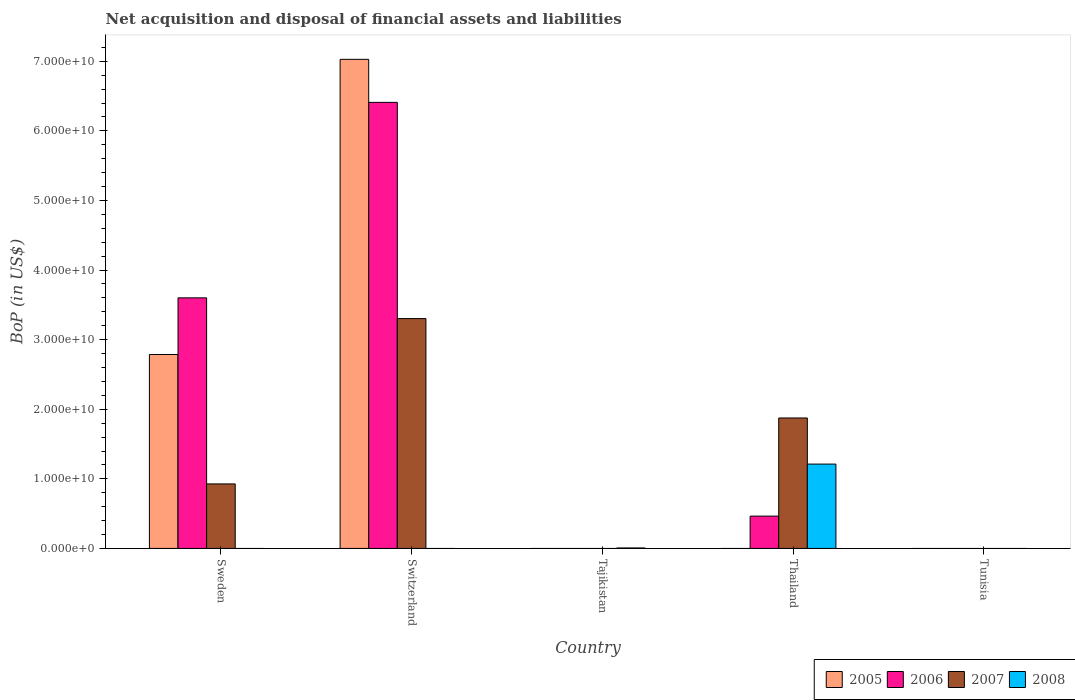Are the number of bars on each tick of the X-axis equal?
Offer a very short reply. No. How many bars are there on the 3rd tick from the left?
Your answer should be very brief. 1. How many bars are there on the 5th tick from the right?
Offer a terse response. 3. What is the label of the 5th group of bars from the left?
Offer a very short reply. Tunisia. In how many cases, is the number of bars for a given country not equal to the number of legend labels?
Your answer should be compact. 5. What is the Balance of Payments in 2007 in Sweden?
Make the answer very short. 9.27e+09. Across all countries, what is the maximum Balance of Payments in 2007?
Your response must be concise. 3.30e+1. Across all countries, what is the minimum Balance of Payments in 2007?
Ensure brevity in your answer.  0. In which country was the Balance of Payments in 2006 maximum?
Your response must be concise. Switzerland. What is the total Balance of Payments in 2006 in the graph?
Offer a very short reply. 1.05e+11. What is the difference between the Balance of Payments in 2008 in Tajikistan and that in Thailand?
Your response must be concise. -1.21e+1. What is the difference between the Balance of Payments in 2005 in Thailand and the Balance of Payments in 2006 in Tunisia?
Keep it short and to the point. 0. What is the average Balance of Payments in 2006 per country?
Your answer should be compact. 2.09e+1. What is the difference between the Balance of Payments of/in 2007 and Balance of Payments of/in 2005 in Switzerland?
Make the answer very short. -3.73e+1. What is the difference between the highest and the second highest Balance of Payments in 2006?
Provide a short and direct response. 2.81e+1. What is the difference between the highest and the lowest Balance of Payments in 2006?
Offer a terse response. 6.41e+1. Is it the case that in every country, the sum of the Balance of Payments in 2008 and Balance of Payments in 2005 is greater than the sum of Balance of Payments in 2007 and Balance of Payments in 2006?
Provide a short and direct response. No. Is it the case that in every country, the sum of the Balance of Payments in 2007 and Balance of Payments in 2008 is greater than the Balance of Payments in 2005?
Your answer should be compact. No. How many bars are there?
Your answer should be compact. 10. How many countries are there in the graph?
Provide a short and direct response. 5. What is the difference between two consecutive major ticks on the Y-axis?
Give a very brief answer. 1.00e+1. How many legend labels are there?
Give a very brief answer. 4. How are the legend labels stacked?
Offer a very short reply. Horizontal. What is the title of the graph?
Provide a succinct answer. Net acquisition and disposal of financial assets and liabilities. Does "1987" appear as one of the legend labels in the graph?
Offer a terse response. No. What is the label or title of the X-axis?
Your answer should be compact. Country. What is the label or title of the Y-axis?
Your answer should be very brief. BoP (in US$). What is the BoP (in US$) of 2005 in Sweden?
Your answer should be compact. 2.79e+1. What is the BoP (in US$) of 2006 in Sweden?
Your response must be concise. 3.60e+1. What is the BoP (in US$) of 2007 in Sweden?
Keep it short and to the point. 9.27e+09. What is the BoP (in US$) of 2005 in Switzerland?
Make the answer very short. 7.03e+1. What is the BoP (in US$) in 2006 in Switzerland?
Provide a succinct answer. 6.41e+1. What is the BoP (in US$) of 2007 in Switzerland?
Make the answer very short. 3.30e+1. What is the BoP (in US$) in 2008 in Switzerland?
Provide a succinct answer. 0. What is the BoP (in US$) in 2005 in Tajikistan?
Your response must be concise. 0. What is the BoP (in US$) in 2007 in Tajikistan?
Give a very brief answer. 0. What is the BoP (in US$) of 2008 in Tajikistan?
Make the answer very short. 6.87e+07. What is the BoP (in US$) in 2006 in Thailand?
Make the answer very short. 4.64e+09. What is the BoP (in US$) in 2007 in Thailand?
Your answer should be very brief. 1.87e+1. What is the BoP (in US$) in 2008 in Thailand?
Keep it short and to the point. 1.21e+1. What is the BoP (in US$) in 2005 in Tunisia?
Offer a very short reply. 0. What is the BoP (in US$) in 2007 in Tunisia?
Ensure brevity in your answer.  0. Across all countries, what is the maximum BoP (in US$) of 2005?
Your response must be concise. 7.03e+1. Across all countries, what is the maximum BoP (in US$) of 2006?
Offer a very short reply. 6.41e+1. Across all countries, what is the maximum BoP (in US$) of 2007?
Your answer should be very brief. 3.30e+1. Across all countries, what is the maximum BoP (in US$) in 2008?
Your answer should be very brief. 1.21e+1. Across all countries, what is the minimum BoP (in US$) in 2006?
Your answer should be very brief. 0. Across all countries, what is the minimum BoP (in US$) of 2008?
Your response must be concise. 0. What is the total BoP (in US$) of 2005 in the graph?
Provide a succinct answer. 9.81e+1. What is the total BoP (in US$) in 2006 in the graph?
Provide a succinct answer. 1.05e+11. What is the total BoP (in US$) in 2007 in the graph?
Your answer should be very brief. 6.10e+1. What is the total BoP (in US$) of 2008 in the graph?
Keep it short and to the point. 1.22e+1. What is the difference between the BoP (in US$) in 2005 in Sweden and that in Switzerland?
Make the answer very short. -4.24e+1. What is the difference between the BoP (in US$) in 2006 in Sweden and that in Switzerland?
Keep it short and to the point. -2.81e+1. What is the difference between the BoP (in US$) in 2007 in Sweden and that in Switzerland?
Offer a terse response. -2.38e+1. What is the difference between the BoP (in US$) of 2006 in Sweden and that in Thailand?
Offer a terse response. 3.14e+1. What is the difference between the BoP (in US$) in 2007 in Sweden and that in Thailand?
Your answer should be very brief. -9.48e+09. What is the difference between the BoP (in US$) of 2006 in Switzerland and that in Thailand?
Offer a terse response. 5.95e+1. What is the difference between the BoP (in US$) in 2007 in Switzerland and that in Thailand?
Provide a short and direct response. 1.43e+1. What is the difference between the BoP (in US$) of 2008 in Tajikistan and that in Thailand?
Give a very brief answer. -1.21e+1. What is the difference between the BoP (in US$) of 2005 in Sweden and the BoP (in US$) of 2006 in Switzerland?
Offer a terse response. -3.62e+1. What is the difference between the BoP (in US$) of 2005 in Sweden and the BoP (in US$) of 2007 in Switzerland?
Your response must be concise. -5.16e+09. What is the difference between the BoP (in US$) of 2006 in Sweden and the BoP (in US$) of 2007 in Switzerland?
Your response must be concise. 2.98e+09. What is the difference between the BoP (in US$) of 2005 in Sweden and the BoP (in US$) of 2008 in Tajikistan?
Ensure brevity in your answer.  2.78e+1. What is the difference between the BoP (in US$) in 2006 in Sweden and the BoP (in US$) in 2008 in Tajikistan?
Your answer should be compact. 3.59e+1. What is the difference between the BoP (in US$) of 2007 in Sweden and the BoP (in US$) of 2008 in Tajikistan?
Your response must be concise. 9.20e+09. What is the difference between the BoP (in US$) of 2005 in Sweden and the BoP (in US$) of 2006 in Thailand?
Keep it short and to the point. 2.32e+1. What is the difference between the BoP (in US$) of 2005 in Sweden and the BoP (in US$) of 2007 in Thailand?
Your answer should be very brief. 9.12e+09. What is the difference between the BoP (in US$) in 2005 in Sweden and the BoP (in US$) in 2008 in Thailand?
Your answer should be compact. 1.57e+1. What is the difference between the BoP (in US$) in 2006 in Sweden and the BoP (in US$) in 2007 in Thailand?
Your answer should be compact. 1.73e+1. What is the difference between the BoP (in US$) of 2006 in Sweden and the BoP (in US$) of 2008 in Thailand?
Provide a short and direct response. 2.39e+1. What is the difference between the BoP (in US$) in 2007 in Sweden and the BoP (in US$) in 2008 in Thailand?
Your answer should be compact. -2.85e+09. What is the difference between the BoP (in US$) of 2005 in Switzerland and the BoP (in US$) of 2008 in Tajikistan?
Ensure brevity in your answer.  7.02e+1. What is the difference between the BoP (in US$) in 2006 in Switzerland and the BoP (in US$) in 2008 in Tajikistan?
Give a very brief answer. 6.40e+1. What is the difference between the BoP (in US$) in 2007 in Switzerland and the BoP (in US$) in 2008 in Tajikistan?
Your answer should be very brief. 3.30e+1. What is the difference between the BoP (in US$) of 2005 in Switzerland and the BoP (in US$) of 2006 in Thailand?
Offer a terse response. 6.56e+1. What is the difference between the BoP (in US$) in 2005 in Switzerland and the BoP (in US$) in 2007 in Thailand?
Provide a short and direct response. 5.15e+1. What is the difference between the BoP (in US$) in 2005 in Switzerland and the BoP (in US$) in 2008 in Thailand?
Provide a succinct answer. 5.82e+1. What is the difference between the BoP (in US$) of 2006 in Switzerland and the BoP (in US$) of 2007 in Thailand?
Offer a very short reply. 4.53e+1. What is the difference between the BoP (in US$) in 2006 in Switzerland and the BoP (in US$) in 2008 in Thailand?
Your answer should be compact. 5.20e+1. What is the difference between the BoP (in US$) in 2007 in Switzerland and the BoP (in US$) in 2008 in Thailand?
Keep it short and to the point. 2.09e+1. What is the average BoP (in US$) of 2005 per country?
Your answer should be compact. 1.96e+1. What is the average BoP (in US$) in 2006 per country?
Offer a terse response. 2.09e+1. What is the average BoP (in US$) in 2007 per country?
Your answer should be compact. 1.22e+1. What is the average BoP (in US$) in 2008 per country?
Provide a short and direct response. 2.44e+09. What is the difference between the BoP (in US$) in 2005 and BoP (in US$) in 2006 in Sweden?
Provide a succinct answer. -8.14e+09. What is the difference between the BoP (in US$) of 2005 and BoP (in US$) of 2007 in Sweden?
Provide a succinct answer. 1.86e+1. What is the difference between the BoP (in US$) of 2006 and BoP (in US$) of 2007 in Sweden?
Keep it short and to the point. 2.67e+1. What is the difference between the BoP (in US$) in 2005 and BoP (in US$) in 2006 in Switzerland?
Offer a very short reply. 6.18e+09. What is the difference between the BoP (in US$) of 2005 and BoP (in US$) of 2007 in Switzerland?
Keep it short and to the point. 3.73e+1. What is the difference between the BoP (in US$) of 2006 and BoP (in US$) of 2007 in Switzerland?
Give a very brief answer. 3.11e+1. What is the difference between the BoP (in US$) of 2006 and BoP (in US$) of 2007 in Thailand?
Provide a succinct answer. -1.41e+1. What is the difference between the BoP (in US$) in 2006 and BoP (in US$) in 2008 in Thailand?
Ensure brevity in your answer.  -7.48e+09. What is the difference between the BoP (in US$) of 2007 and BoP (in US$) of 2008 in Thailand?
Give a very brief answer. 6.63e+09. What is the ratio of the BoP (in US$) of 2005 in Sweden to that in Switzerland?
Your answer should be compact. 0.4. What is the ratio of the BoP (in US$) in 2006 in Sweden to that in Switzerland?
Give a very brief answer. 0.56. What is the ratio of the BoP (in US$) in 2007 in Sweden to that in Switzerland?
Your response must be concise. 0.28. What is the ratio of the BoP (in US$) of 2006 in Sweden to that in Thailand?
Keep it short and to the point. 7.75. What is the ratio of the BoP (in US$) in 2007 in Sweden to that in Thailand?
Provide a succinct answer. 0.49. What is the ratio of the BoP (in US$) in 2006 in Switzerland to that in Thailand?
Your answer should be compact. 13.8. What is the ratio of the BoP (in US$) in 2007 in Switzerland to that in Thailand?
Offer a terse response. 1.76. What is the ratio of the BoP (in US$) in 2008 in Tajikistan to that in Thailand?
Give a very brief answer. 0.01. What is the difference between the highest and the second highest BoP (in US$) in 2006?
Your answer should be compact. 2.81e+1. What is the difference between the highest and the second highest BoP (in US$) of 2007?
Provide a succinct answer. 1.43e+1. What is the difference between the highest and the lowest BoP (in US$) in 2005?
Give a very brief answer. 7.03e+1. What is the difference between the highest and the lowest BoP (in US$) of 2006?
Keep it short and to the point. 6.41e+1. What is the difference between the highest and the lowest BoP (in US$) in 2007?
Offer a terse response. 3.30e+1. What is the difference between the highest and the lowest BoP (in US$) of 2008?
Offer a very short reply. 1.21e+1. 